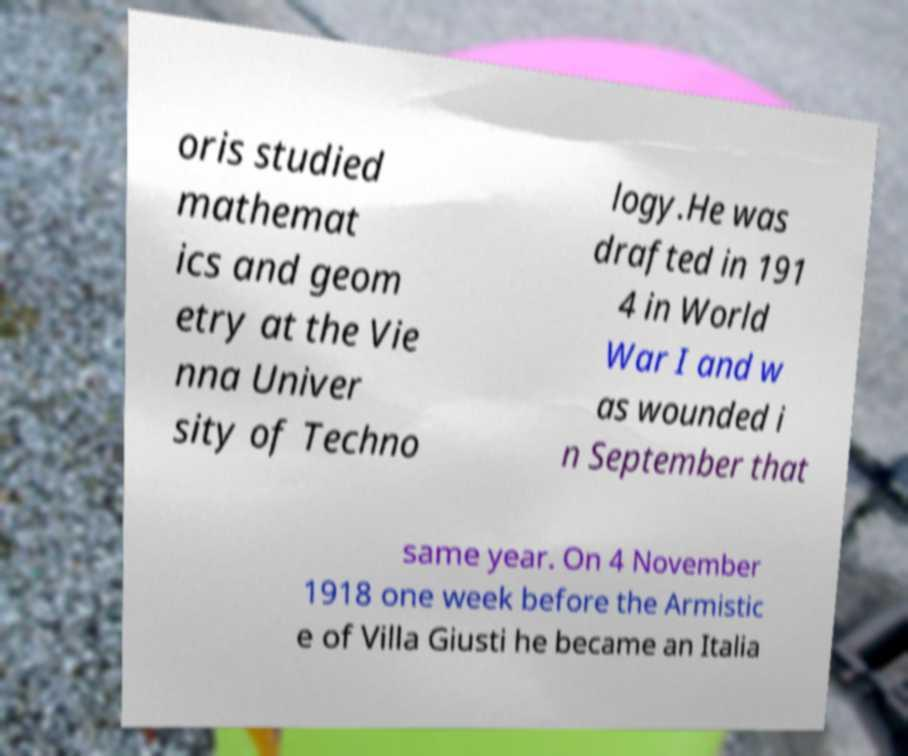Could you extract and type out the text from this image? oris studied mathemat ics and geom etry at the Vie nna Univer sity of Techno logy.He was drafted in 191 4 in World War I and w as wounded i n September that same year. On 4 November 1918 one week before the Armistic e of Villa Giusti he became an Italia 